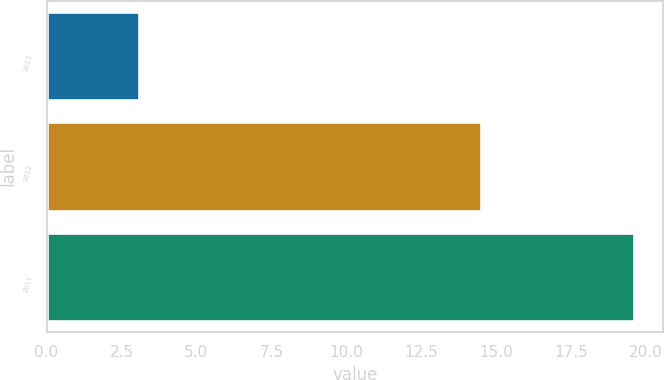Convert chart. <chart><loc_0><loc_0><loc_500><loc_500><bar_chart><fcel>2013<fcel>2012<fcel>2011<nl><fcel>3.1<fcel>14.5<fcel>19.6<nl></chart> 